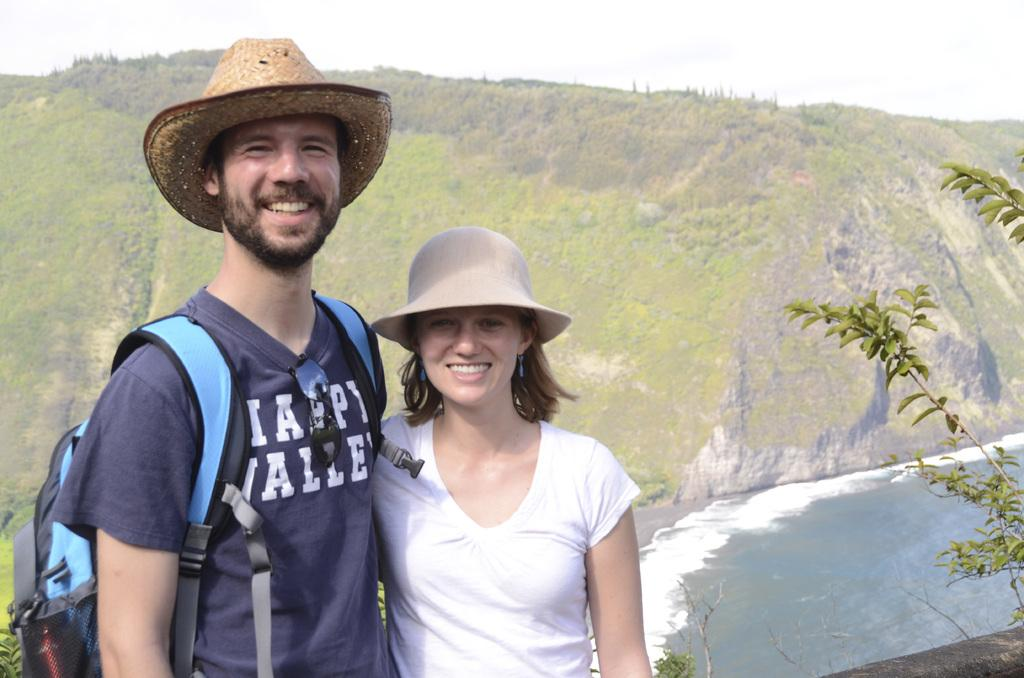<image>
Describe the image concisely. A man and woman are embracing by a cliff and the man's shirt says Valley. 